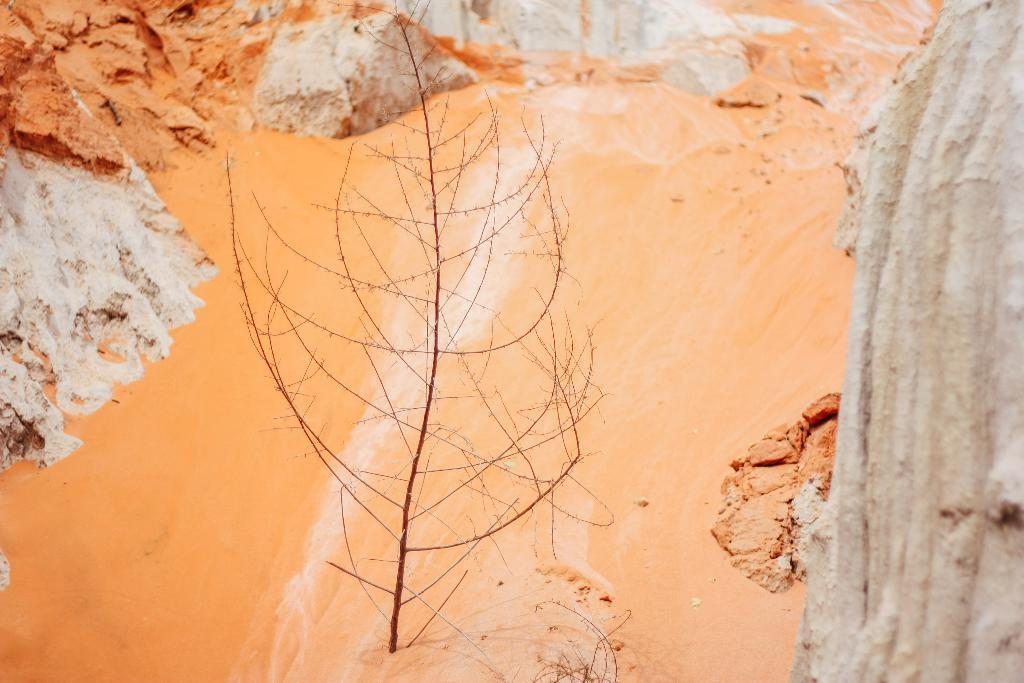What can be seen in the background of the image? There is an orange and white colored thing in the background of the image. What else is present in the image besides the background object? There is an unspecified thing in the image. What type of education is being taught in the image? There is no indication of education or teaching in the image. What instrument is being played in the image? There is no instrument or music-related activity depicted in the image. 